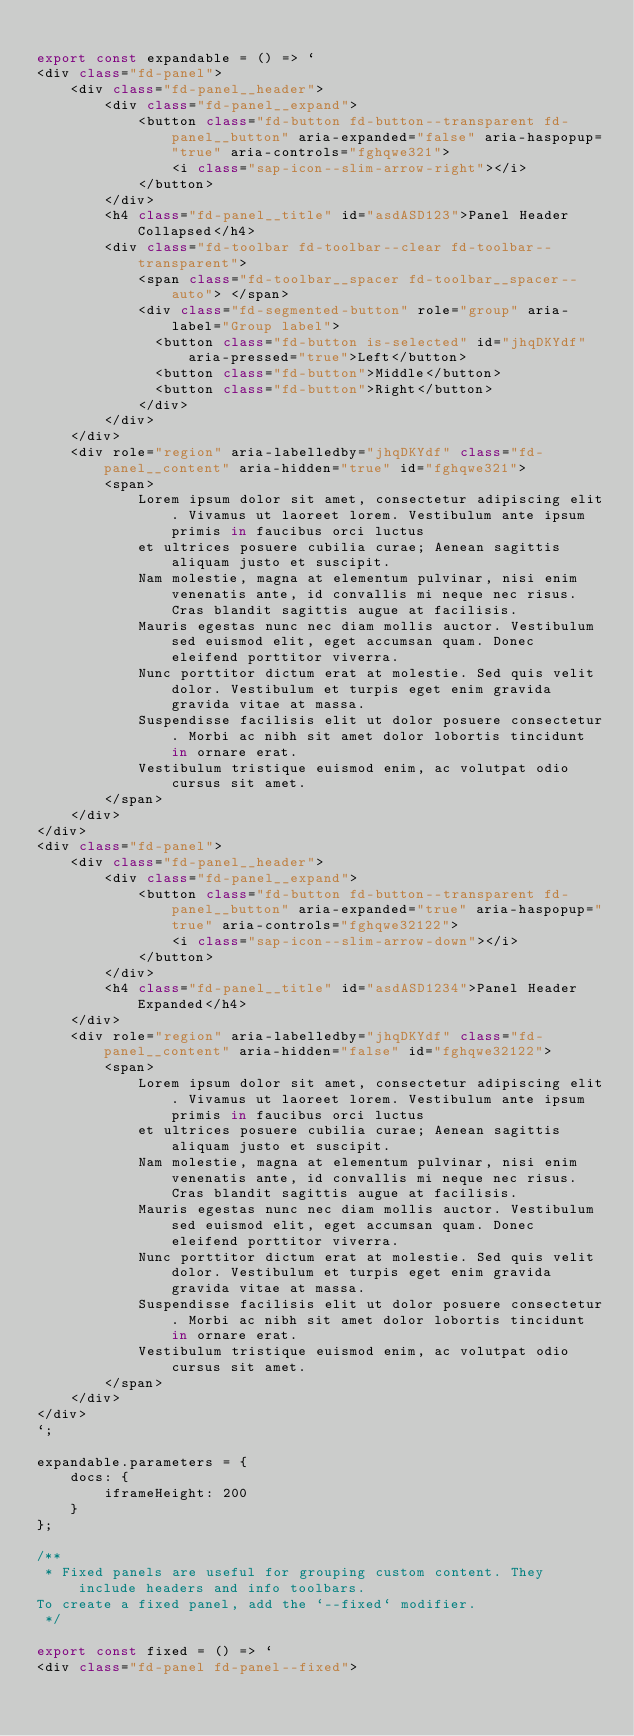Convert code to text. <code><loc_0><loc_0><loc_500><loc_500><_JavaScript_>
export const expandable = () => `
<div class="fd-panel">
    <div class="fd-panel__header">
        <div class="fd-panel__expand">
            <button class="fd-button fd-button--transparent fd-panel__button" aria-expanded="false" aria-haspopup="true" aria-controls="fghqwe321">
                <i class="sap-icon--slim-arrow-right"></i>
            </button>
        </div>
        <h4 class="fd-panel__title" id="asdASD123">Panel Header Collapsed</h4>
        <div class="fd-toolbar fd-toolbar--clear fd-toolbar--transparent">
            <span class="fd-toolbar__spacer fd-toolbar__spacer--auto"> </span>
            <div class="fd-segmented-button" role="group" aria-label="Group label">
              <button class="fd-button is-selected" id="jhqDKYdf" aria-pressed="true">Left</button>
              <button class="fd-button">Middle</button>
              <button class="fd-button">Right</button>
            </div>
        </div>
    </div>
    <div role="region" aria-labelledby="jhqDKYdf" class="fd-panel__content" aria-hidden="true" id="fghqwe321">
        <span>
            Lorem ipsum dolor sit amet, consectetur adipiscing elit. Vivamus ut laoreet lorem. Vestibulum ante ipsum primis in faucibus orci luctus 
            et ultrices posuere cubilia curae; Aenean sagittis aliquam justo et suscipit. 
            Nam molestie, magna at elementum pulvinar, nisi enim venenatis ante, id convallis mi neque nec risus. Cras blandit sagittis augue at facilisis. 
            Mauris egestas nunc nec diam mollis auctor. Vestibulum sed euismod elit, eget accumsan quam. Donec eleifend porttitor viverra. 
            Nunc porttitor dictum erat at molestie. Sed quis velit dolor. Vestibulum et turpis eget enim gravida gravida vitae at massa. 
            Suspendisse facilisis elit ut dolor posuere consectetur. Morbi ac nibh sit amet dolor lobortis tincidunt in ornare erat. 
            Vestibulum tristique euismod enim, ac volutpat odio cursus sit amet.
        </span>
    </div>
</div>
<div class="fd-panel">
    <div class="fd-panel__header">
        <div class="fd-panel__expand">
            <button class="fd-button fd-button--transparent fd-panel__button" aria-expanded="true" aria-haspopup="true" aria-controls="fghqwe32122">
                <i class="sap-icon--slim-arrow-down"></i>
            </button>
        </div>
        <h4 class="fd-panel__title" id="asdASD1234">Panel Header Expanded</h4>
    </div>
    <div role="region" aria-labelledby="jhqDKYdf" class="fd-panel__content" aria-hidden="false" id="fghqwe32122">
        <span>
            Lorem ipsum dolor sit amet, consectetur adipiscing elit. Vivamus ut laoreet lorem. Vestibulum ante ipsum primis in faucibus orci luctus 
            et ultrices posuere cubilia curae; Aenean sagittis aliquam justo et suscipit. 
            Nam molestie, magna at elementum pulvinar, nisi enim venenatis ante, id convallis mi neque nec risus. Cras blandit sagittis augue at facilisis. 
            Mauris egestas nunc nec diam mollis auctor. Vestibulum sed euismod elit, eget accumsan quam. Donec eleifend porttitor viverra. 
            Nunc porttitor dictum erat at molestie. Sed quis velit dolor. Vestibulum et turpis eget enim gravida gravida vitae at massa. 
            Suspendisse facilisis elit ut dolor posuere consectetur. Morbi ac nibh sit amet dolor lobortis tincidunt in ornare erat. 
            Vestibulum tristique euismod enim, ac volutpat odio cursus sit amet.
        </span>
    </div>
</div>
`;

expandable.parameters = {
    docs: {
        iframeHeight: 200
    }
};

/**
 * Fixed panels are useful for grouping custom content. They include headers and info toolbars.
To create a fixed panel, add the `--fixed` modifier.
 */

export const fixed = () => `
<div class="fd-panel fd-panel--fixed"></code> 